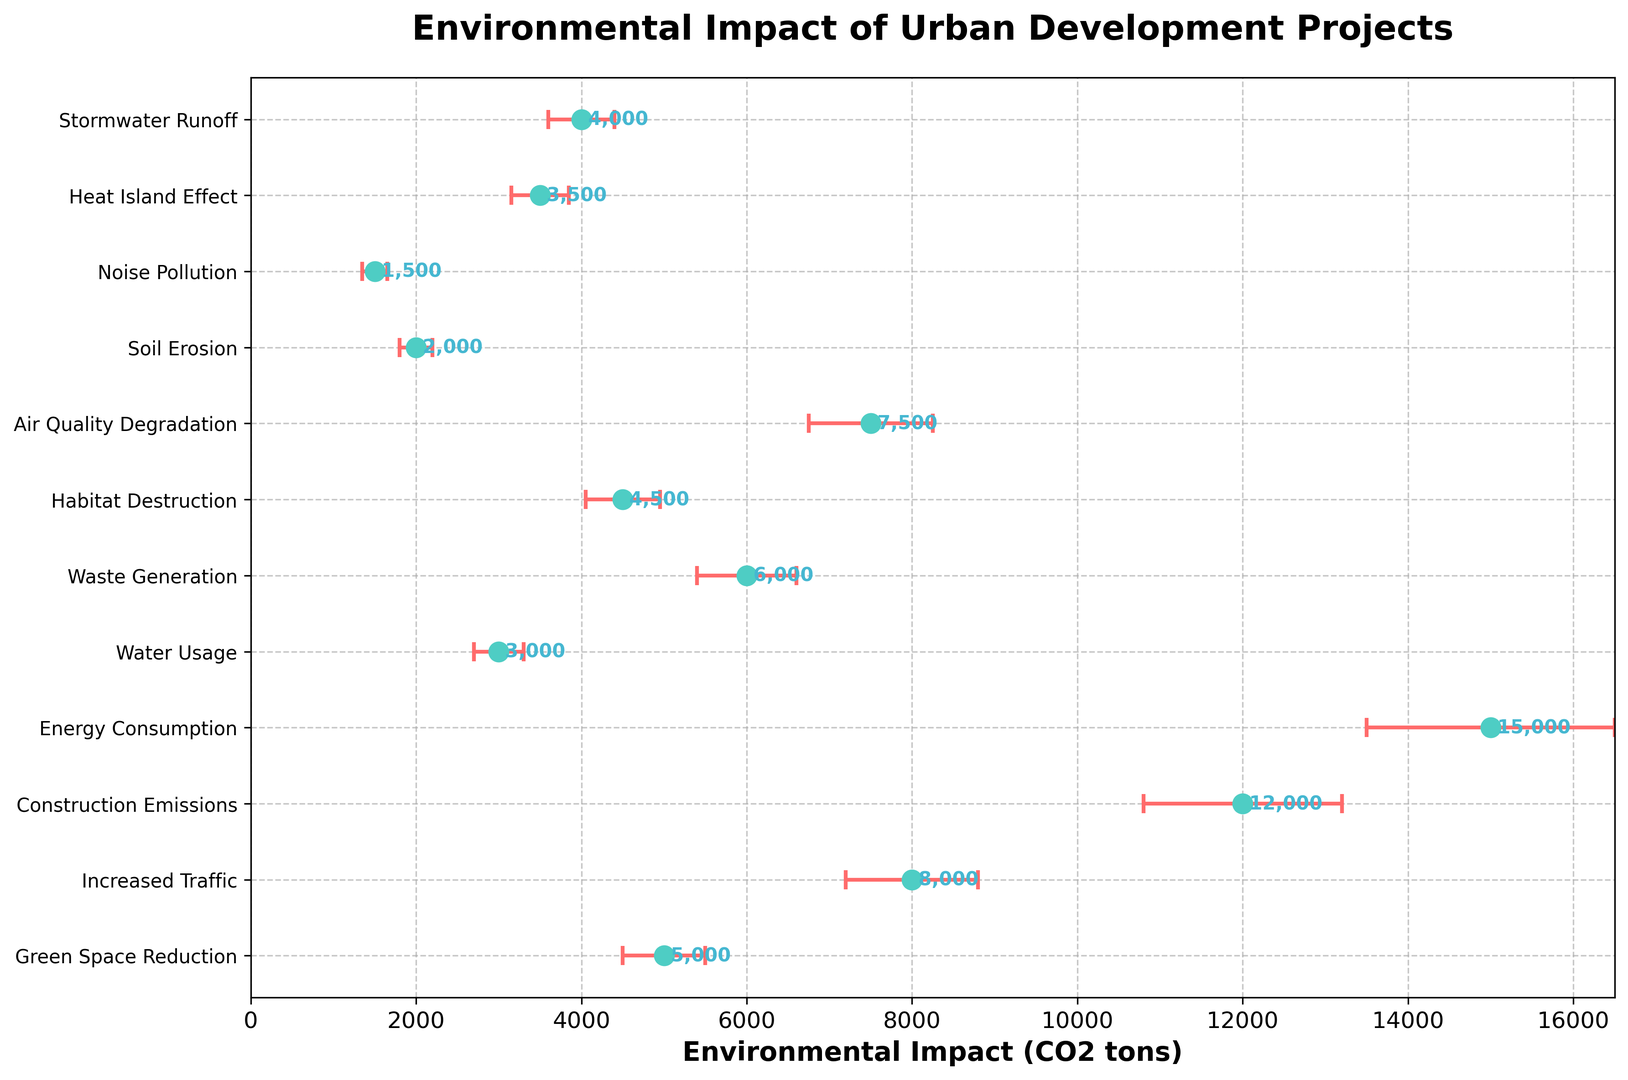Which urban development project contributes the most to environmental impact in terms of CO2 tons? From the figure, the project with the highest CO2 impact is determined by the length of its marker on the x-axis. The "Energy Consumption" project shows the highest impact, extending to 15,000 CO2 tons.
Answer: Energy Consumption Which project has the lowest associated environmental impact? By looking at the shortest length of the error bar's marker on the x-axis, the "Noise Pollution" project has the lowest environmental impact at 1,500 CO2 tons.
Answer: Noise Pollution What is the sum of the CO2 impact for the projects "Water Usage" and "Stormwater Runoff"? Sum the CO2 impact of "Water Usage" and "Stormwater Runoff." The impact for "Water Usage" is 3,000 CO2 tons and for "Stormwater Runoff" is 4,000 CO2 tons. Adding them together: 3,000 + 4,000 = 7,000 CO2 tons.
Answer: 7,000 CO2 tons Which project has a higher environmental impact, "Green Space Reduction" or "Habitat Destruction"? Compare the x-axis lengths of "Green Space Reduction" (5,000 CO2 tons) and "Habitat Destruction" (4,500 CO2 tons). Therefore, "Green Space Reduction" has the higher environmental impact.
Answer: Green Space Reduction What is the difference in the CO2 impact between "Increased Traffic" and "Air Quality Degradation"? Subtract the CO2 impact of "Air Quality Degradation" from "Increased Traffic": 8,000 - 7,500 = 500 CO2 tons.
Answer: 500 CO2 tons What is the range of uncertainty for the project "Construction Emissions"? The uncertainty range is the difference between the upper and lower uncertainty bounds. For "Construction Emissions," it ranges from 10,800 to 13,200 CO2 tons: 13,200 - 10,800 = 2,400 CO2 tons.
Answer: 2,400 CO2 tons Which projects have an environmental impact greater than 5,000 CO2 tons? Identify projects with markers exceeding the 5,000 mark on the x-axis: "Increased Traffic" (8,000), "Construction Emissions" (12,000), "Energy Consumption" (15,000), "Air Quality Degradation" (7,500), and "Waste Generation" (6,000).
Answer: Increased Traffic, Construction Emissions, Energy Consumption, Air Quality Degradation, Waste Generation What is the average CO2 impact of all the projects? Sum all CO2 impacts and divide by the number of projects. Sum is 5,000 + 8,000 + 12,000 + 15,000 + 3,000 + 6,000 + 4,500 + 7,500 + 2,000 + 1,500 + 3,500 + 4,000 = 72,000. There are 12 projects, so: 72,000 / 12 = 6,000 CO2 tons.
Answer: 6,000 CO2 tons How does the environmental impact of "Increased Traffic" compare to "Construction Emissions"? "Increased Traffic" has a CO2 impact of 8,000 tons, whereas "Construction Emissions" has a higher impact at 12,000 tons.
Answer: Construction Emissions has a greater impact What is the combined uncertainty range of "Heat Island Effect" and "Soil Erosion"? Combine the uncertainty ranges by summing the differences: "Heat Island Effect" = 3,850 - 3,150 = 700 CO2 tons and "Soil Erosion" = 2,200 - 1,800 = 400 CO2 tons. Adding them gives 700 + 400 = 1,100 CO2 tons.
Answer: 1,100 CO2 tons 